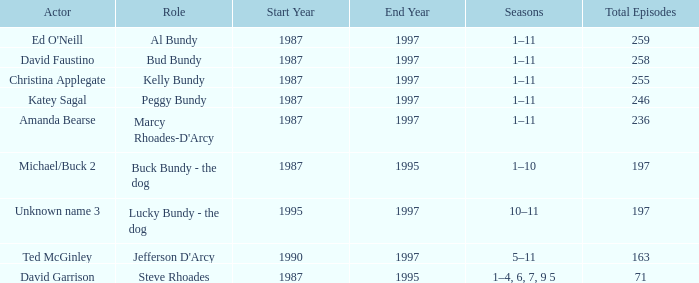How many years did the role of Steve Rhoades last? 1987–90, 1992, 1993, 1995. 